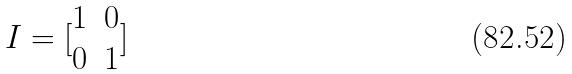<formula> <loc_0><loc_0><loc_500><loc_500>I = [ \begin{matrix} 1 & 0 \\ 0 & 1 \end{matrix} ]</formula> 